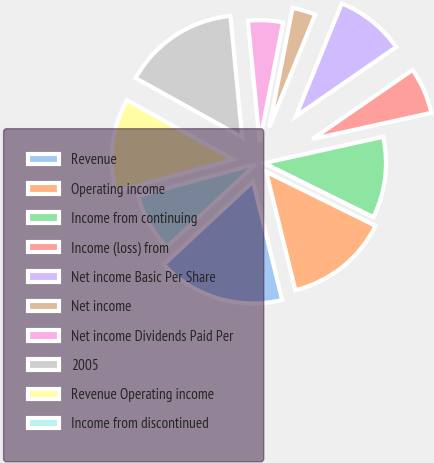<chart> <loc_0><loc_0><loc_500><loc_500><pie_chart><fcel>Revenue<fcel>Operating income<fcel>Income from continuing<fcel>Income (loss) from<fcel>Net income Basic Per Share<fcel>Net income<fcel>Net income Dividends Paid Per<fcel>2005<fcel>Revenue Operating income<fcel>Income from discontinued<nl><fcel>16.92%<fcel>13.85%<fcel>10.77%<fcel>6.15%<fcel>9.23%<fcel>3.08%<fcel>4.62%<fcel>15.38%<fcel>12.31%<fcel>7.69%<nl></chart> 